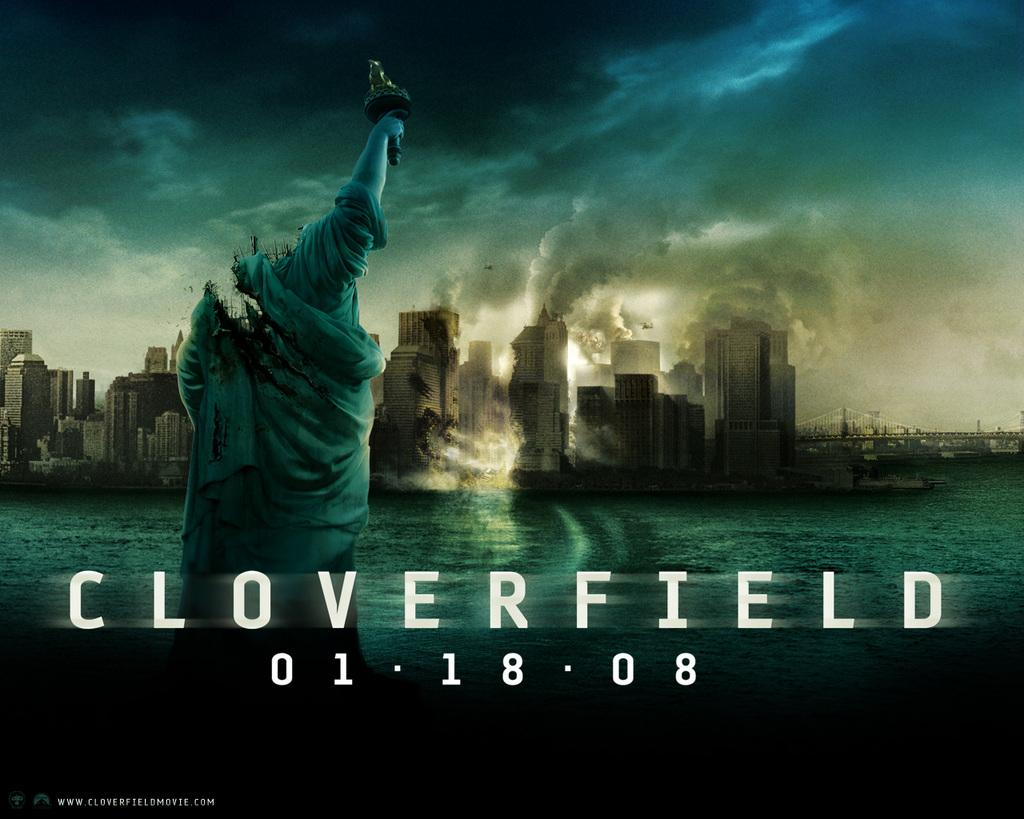<image>
Create a compact narrative representing the image presented. A movie poster for the movie Cloverfield shows the statue of Liberty destroyed. 